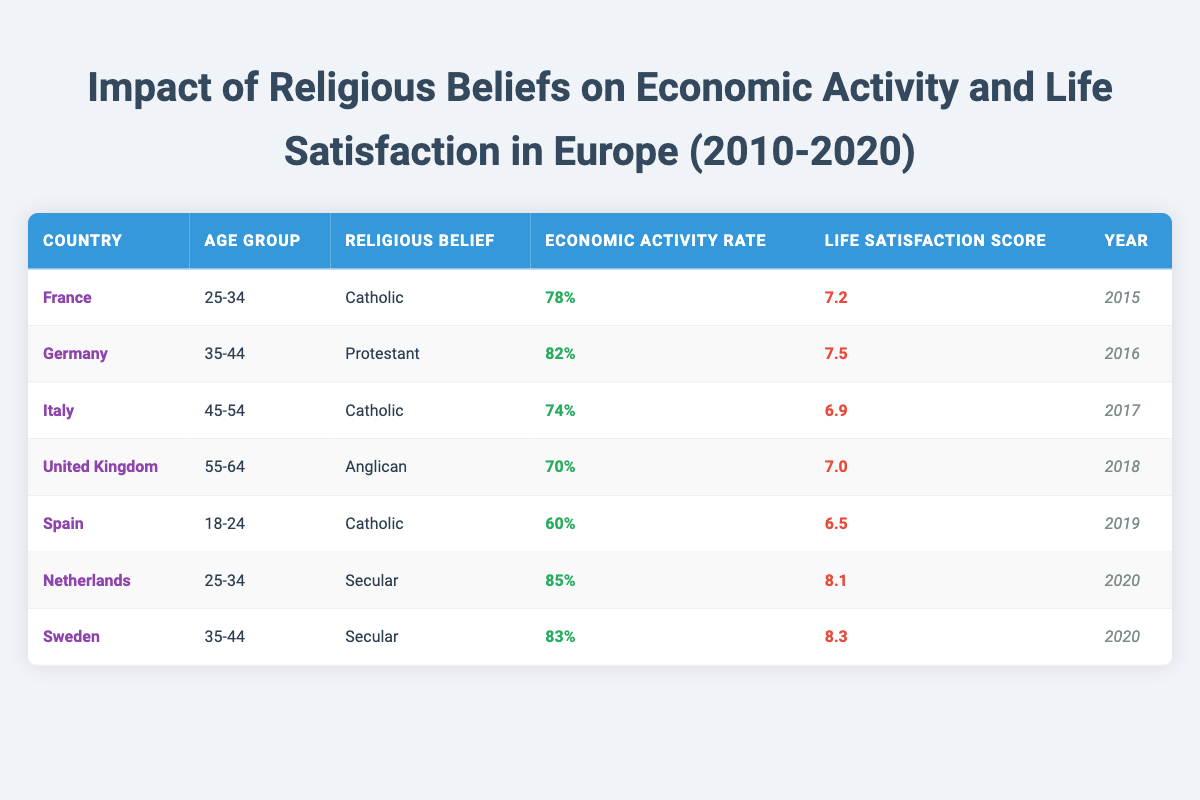What is the life satisfaction score for Italy in 2017? The table lists Italy's life satisfaction score as 6.9 for the year 2017.
Answer: 6.9 What is the economic activity rate of young adults (ages 18-24) in Spain? The table shows that the economic activity rate for the age group 18-24 in Spain is 60%.
Answer: 60% Which country has the highest economic activity rate? By examining the economic activity rates, the highest is 85% for the Netherlands in 2020.
Answer: 85% Is the life satisfaction score for secular individuals generally higher than for Catholic individuals based on the available data? Comparing life satisfaction scores, secular individuals scored 8.1 and 8.3, while Catholics scored 7.2, 6.9, and 6.5. Secular individuals are indeed higher.
Answer: Yes What is the average life satisfaction score for all entries in the table? The life satisfaction scores are 7.2, 7.5, 6.9, 7.0, 6.5, 8.1, and 8.3. The average is calculated as (7.2 + 7.5 + 6.9 + 7.0 + 6.5 + 8.1 + 8.3) / 7 = 7.2.
Answer: 7.2 Which religious belief is associated with the lowest economic activity rate in the table? The economic activity rates for Catholics in France (78%), Italy (74%), and Spain (60%) and the lowest is 60% for Spain.
Answer: Catholic For which country and age group is the economic activity rate 82%? The entry for Germany in the age group 35-44 has an economic activity rate of 82%.
Answer: Germany, 35-44 What can be inferred about the relationship between religious belief and life satisfaction based on the data provided? Analyzing the data, secular individuals show higher life satisfaction scores (8.1 and 8.3) than Catholic individuals (7.2, 6.9, and 6.5), indicating a potential positive correlation between secular beliefs and life satisfaction.
Answer: Secular individuals tend to have higher life satisfaction scores 